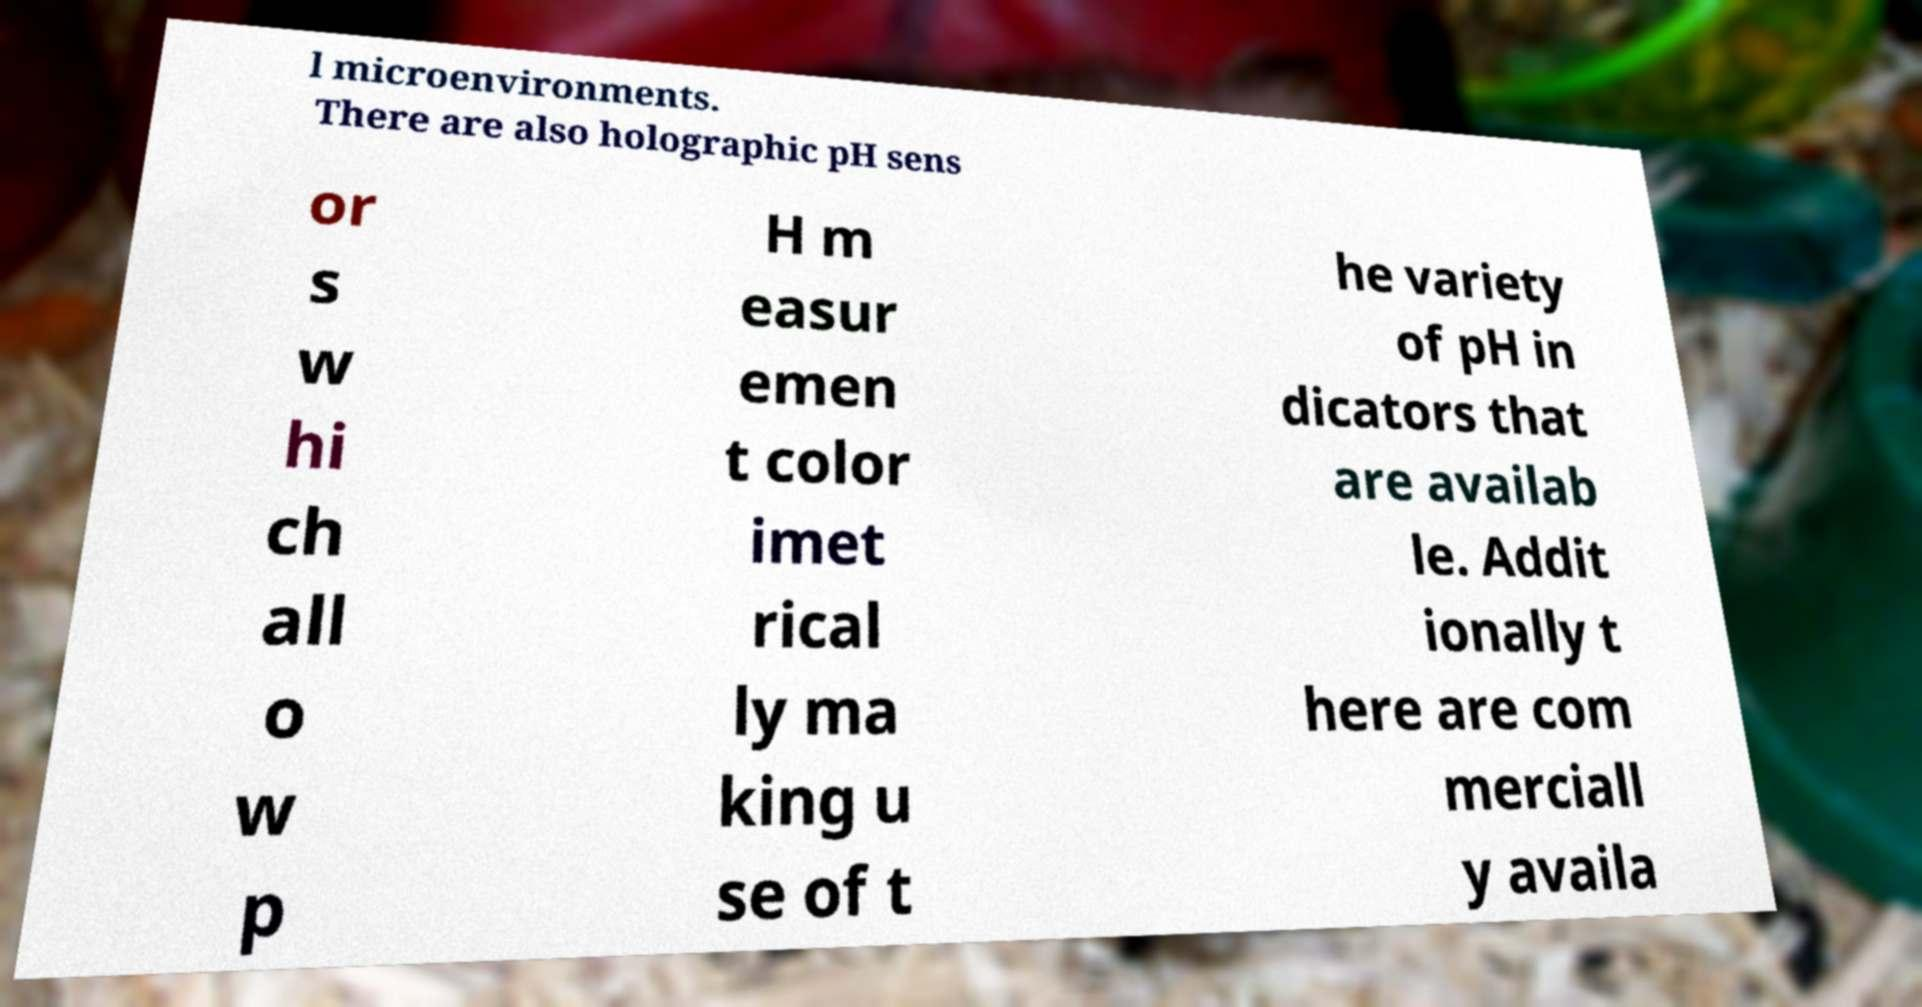There's text embedded in this image that I need extracted. Can you transcribe it verbatim? l microenvironments. There are also holographic pH sens or s w hi ch all o w p H m easur emen t color imet rical ly ma king u se of t he variety of pH in dicators that are availab le. Addit ionally t here are com merciall y availa 